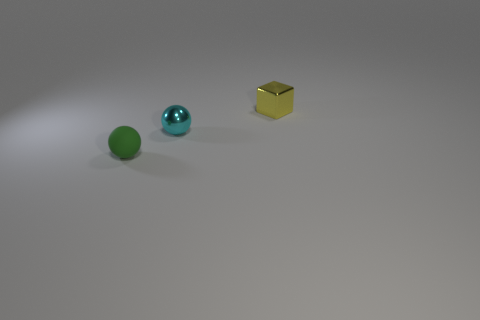Is there a block that has the same material as the green ball?
Your answer should be compact. No. Is the size of the ball behind the small rubber thing the same as the object that is in front of the small cyan shiny thing?
Your answer should be compact. Yes. What size is the ball left of the tiny cyan sphere?
Make the answer very short. Small. Are there any small metallic spheres of the same color as the metallic cube?
Ensure brevity in your answer.  No. There is a sphere on the right side of the small green object; is there a cyan thing that is on the left side of it?
Offer a terse response. No. There is a yellow thing; is its size the same as the metallic thing in front of the small yellow metallic block?
Provide a succinct answer. Yes. Are there any tiny cyan metal things behind the tiny rubber thing in front of the shiny thing that is in front of the yellow object?
Make the answer very short. Yes. There is a ball that is left of the small metal sphere; what is it made of?
Give a very brief answer. Rubber. Does the yellow block have the same size as the cyan thing?
Your response must be concise. Yes. There is a small object that is to the right of the green rubber sphere and in front of the small yellow metallic thing; what color is it?
Your answer should be very brief. Cyan. 